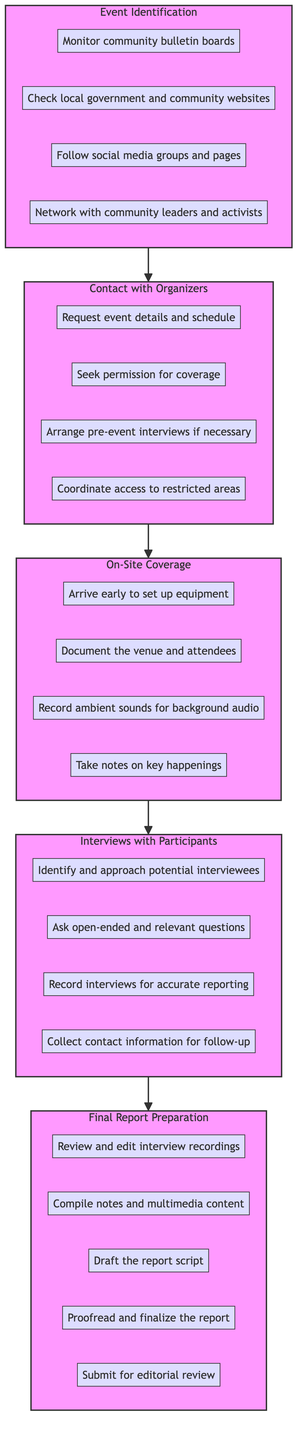What is the first block in the diagram? The diagram starts with the "Event Identification" block. It is the first step in the sequence of the community event reporting plan.
Answer: Event Identification How many steps are there in the "On-Site Coverage" block? The "On-Site Coverage" block contains four steps, which are outlined within that specific block in the diagram.
Answer: 4 What is the last step in the "Final Report Preparation" block? The last step of the "Final Report Preparation" block is "Submit for editorial review," which comes after all the previous steps are completed.
Answer: Submit for editorial review Which block directly follows "Contact with Organizers"? The block that directly follows "Contact with Organizers" is "On-Site Coverage." This is a sequential relationship in the workflow represented in the diagram.
Answer: On-Site Coverage What do the steps under "Interviews with Participants" focus on? The steps under "Interviews with Participants" focus on identifying interviewees, conducting interviews, recording them for accuracy, and collecting their contact information for follow-up. This addresses gathering qualitative data for the report.
Answer: Interviewing participants 